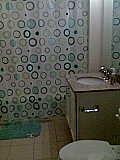Is there a sink here?
Give a very brief answer. Yes. How many rugs are in the bathroom?
Write a very short answer. 1. Where are tiles?
Quick response, please. Floor. What is in the background of the image?
Quick response, please. Shower curtain. How many people are in the shower?
Answer briefly. 0. What color is the sink?
Concise answer only. White. Are there words on the shower curtain?
Keep it brief. No. Is the toilet paper empty?
Short answer required. Yes. Where is the floor mat?
Give a very brief answer. Bathroom. 